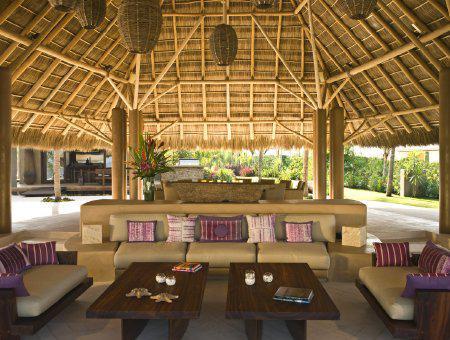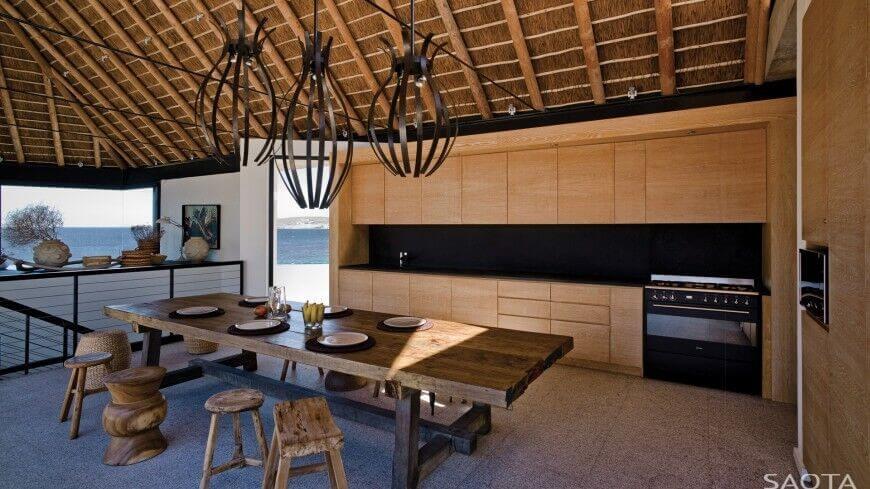The first image is the image on the left, the second image is the image on the right. Assess this claim about the two images: "The left and right image contains both an external view of the building and internal view of a resort.". Correct or not? Answer yes or no. No. The first image is the image on the left, the second image is the image on the right. Evaluate the accuracy of this statement regarding the images: "Both images are inside.". Is it true? Answer yes or no. Yes. 